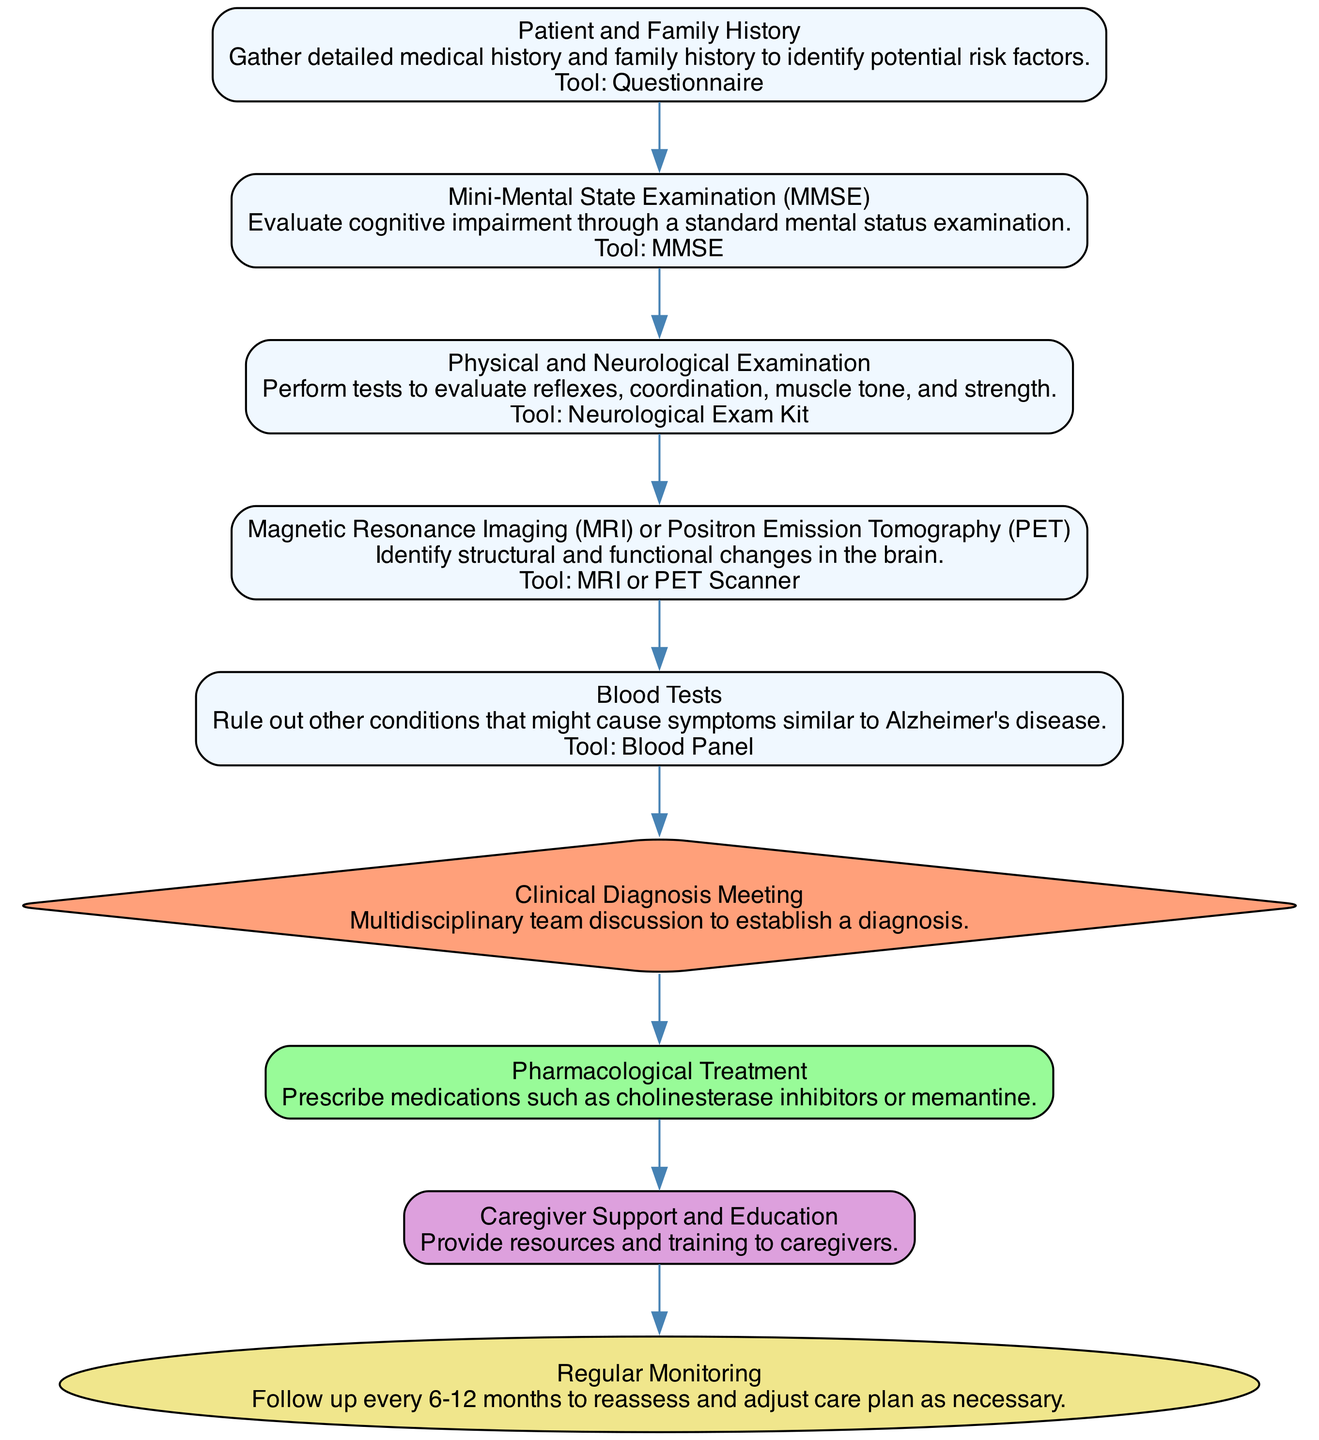What is the first step in the pathway? The first step in the pathway is "Patient and Family History," which gathers detailed medical history and family background.
Answer: Patient and Family History How many tools are listed in the pathway? The pathway contains five tools associated with different steps: Questionnaire, MMSE, Neurological Exam Kit, MRI or PET Scanner, and Blood Panel. Counting these gives a total of five tools.
Answer: 5 Which step involves multidisciplinary team discussion? The step that involves a multidisciplinary team discussion is "Clinical Diagnosis Meeting." This step is explicitly described to involve a team including a neurologist, geriatrician, and neuropsychologist.
Answer: Clinical Diagnosis Meeting What are the medications prescribed for early intervention? The medications prescribed for early intervention include Donepezil, Rivastigmine, Galantamine, and Memantine. These are clearly mentioned under the "Pharmacological Treatment" step.
Answer: Donepezil, Rivastigmine, Galantamine, Memantine How frequently should follow-up occur? Follow-up should occur every 6-12 months, as specified in the "Regular Monitoring" step. The pathway indicates that this is done biannually.
Answer: Biannually What is the purpose of the "Blood Tests" step? The purpose of the "Blood Tests" step is to rule out other conditions that may cause symptoms similar to Alzheimer's disease, as stated in its description.
Answer: Rule out other conditions In which step is caregiver support provided? Caregiver support is provided in the "Caregiver Support and Education" step, where resources and training are offered to caregivers.
Answer: Caregiver Support and Education What is the last step in this clinical pathway? The last step in the clinical pathway is "Regular Monitoring," which emphasizes the need for ongoing assessment and adjustment of the care plan as necessary.
Answer: Regular Monitoring 